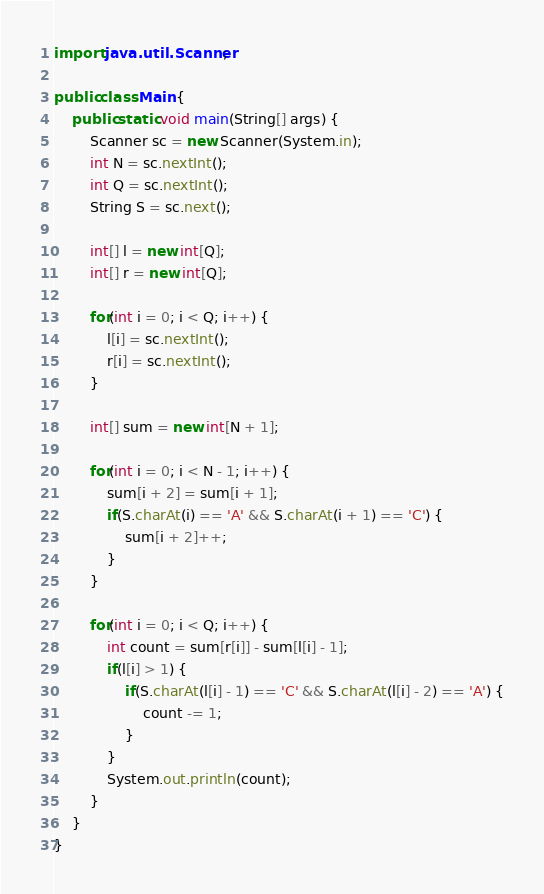<code> <loc_0><loc_0><loc_500><loc_500><_Java_>import java.util.Scanner;

public class Main {
	public static void main(String[] args) {
		Scanner sc = new Scanner(System.in);
		int N = sc.nextInt();
		int Q = sc.nextInt();
		String S = sc.next();
		
		int[] l = new int[Q];
		int[] r = new int[Q];
		
		for(int i = 0; i < Q; i++) {
			l[i] = sc.nextInt();
			r[i] = sc.nextInt();
		}
		
		int[] sum = new int[N + 1];
		
		for(int i = 0; i < N - 1; i++) {
			sum[i + 2] = sum[i + 1];
			if(S.charAt(i) == 'A' && S.charAt(i + 1) == 'C') {
				sum[i + 2]++;
			} 
		}
		
		for(int i = 0; i < Q; i++) {
			int count = sum[r[i]] - sum[l[i] - 1];
			if(l[i] > 1) {
				if(S.charAt(l[i] - 1) == 'C' && S.charAt(l[i] - 2) == 'A') {
					count -= 1;
				}
			}
			System.out.println(count);
		}
	}
}
</code> 